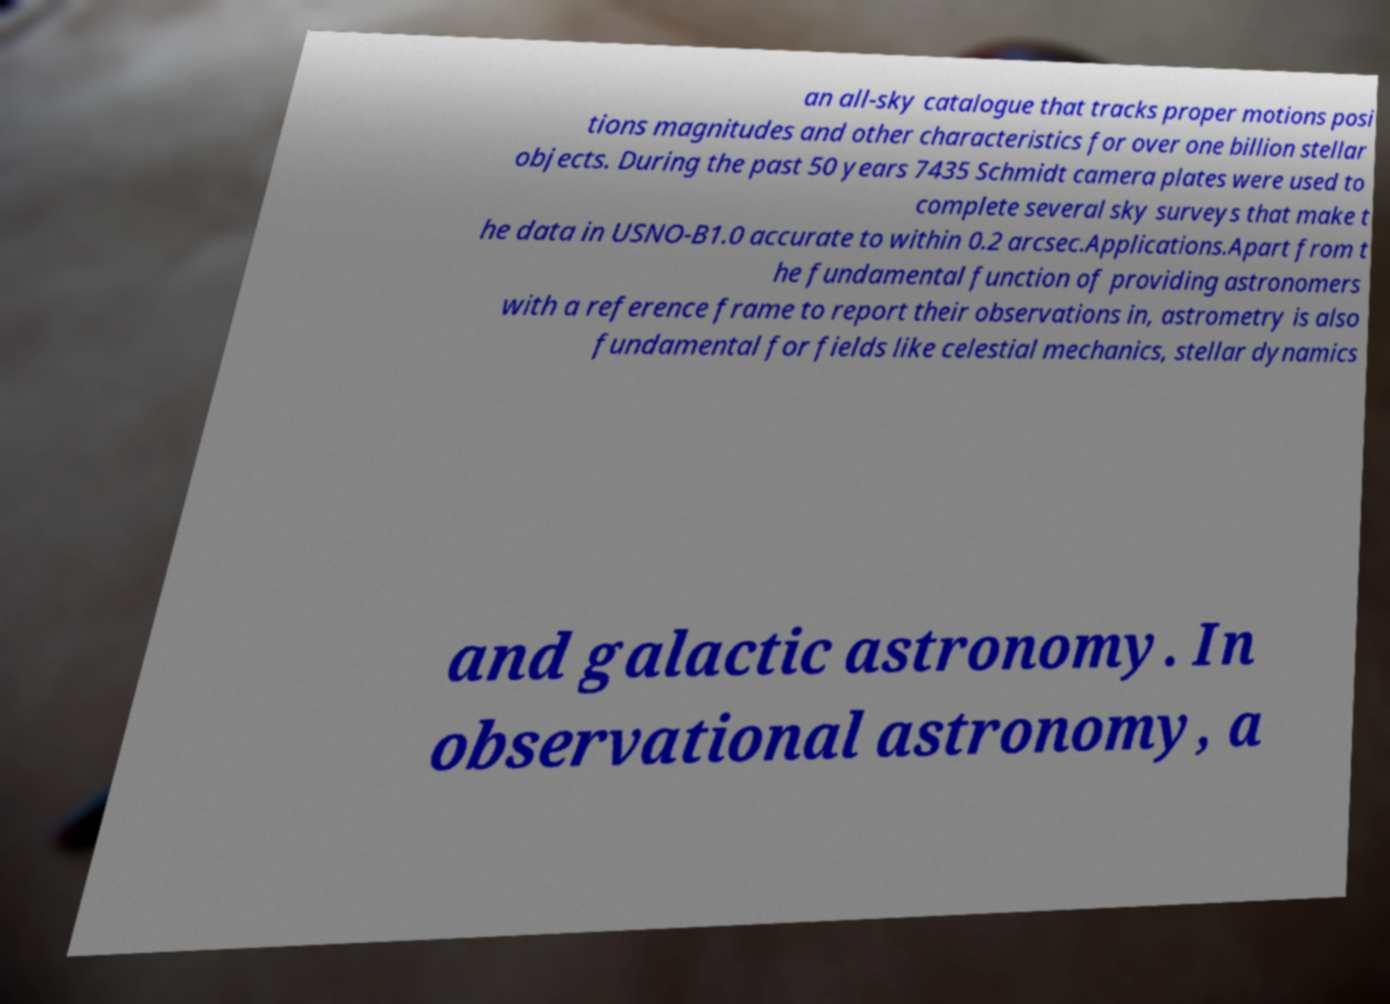What messages or text are displayed in this image? I need them in a readable, typed format. an all-sky catalogue that tracks proper motions posi tions magnitudes and other characteristics for over one billion stellar objects. During the past 50 years 7435 Schmidt camera plates were used to complete several sky surveys that make t he data in USNO-B1.0 accurate to within 0.2 arcsec.Applications.Apart from t he fundamental function of providing astronomers with a reference frame to report their observations in, astrometry is also fundamental for fields like celestial mechanics, stellar dynamics and galactic astronomy. In observational astronomy, a 